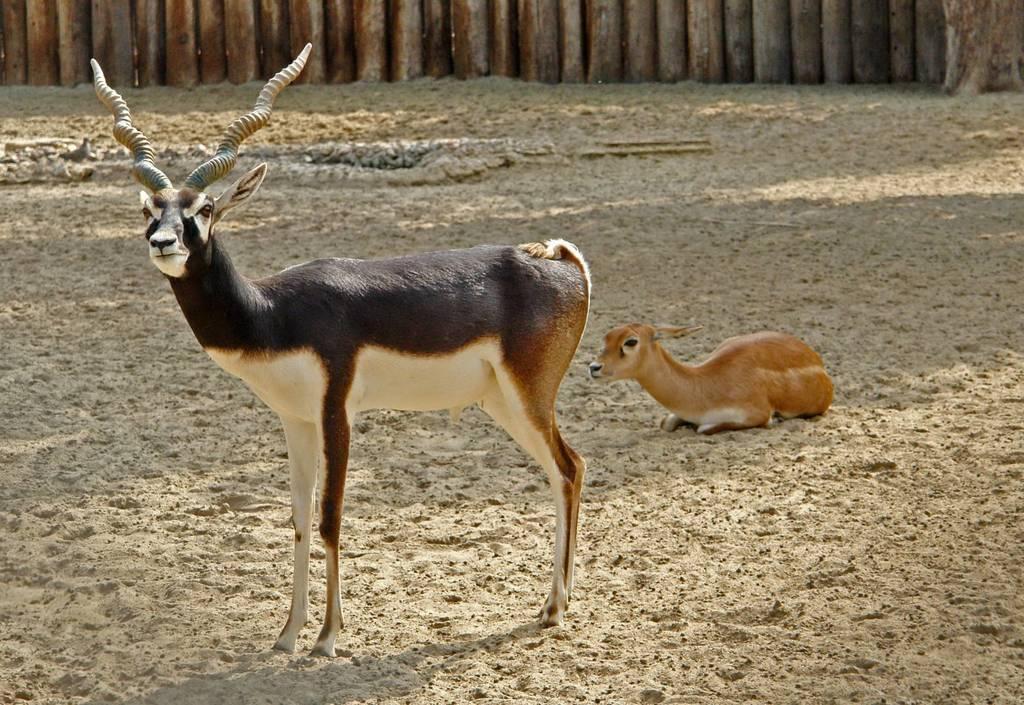Can you describe this image briefly? In this image there are animals and wooden objects. 